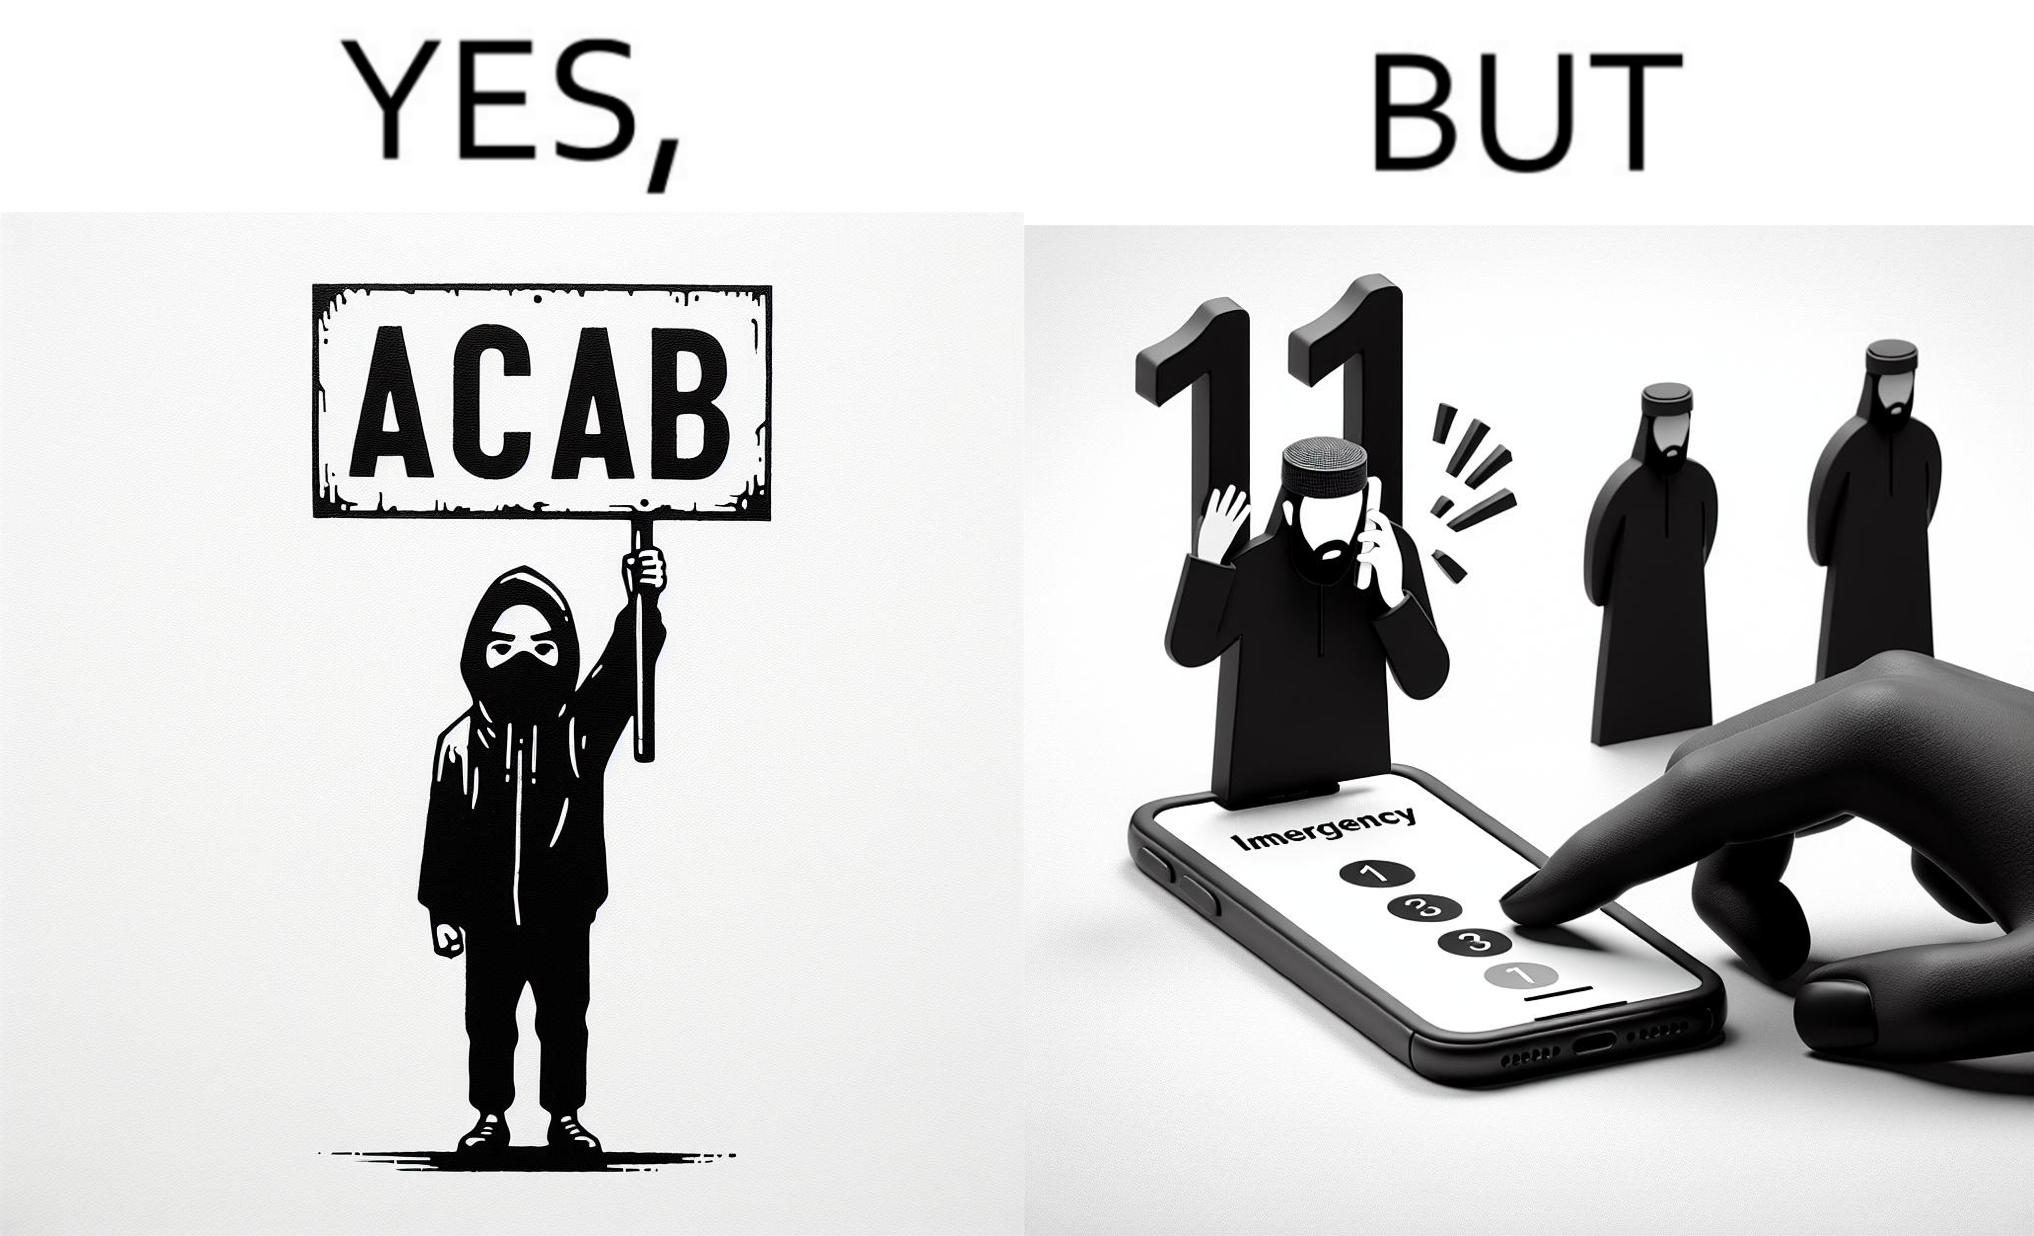Describe the satirical element in this image. This is funny because on the one hand this person is rebelling against cops (slogan being All Cops Are Bad - ACAB), but on the other hand they are also calling the cops for help. 